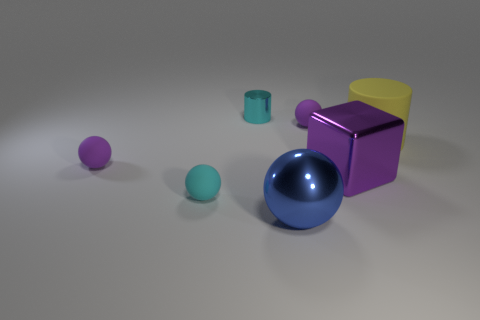Add 2 yellow spheres. How many objects exist? 9 Subtract 1 cylinders. How many cylinders are left? 1 Subtract all cyan matte spheres. How many spheres are left? 3 Subtract all purple balls. How many balls are left? 2 Subtract 0 gray balls. How many objects are left? 7 Subtract all blocks. How many objects are left? 6 Subtract all red cylinders. Subtract all yellow spheres. How many cylinders are left? 2 Subtract all gray cylinders. How many purple spheres are left? 2 Subtract all tiny cyan cylinders. Subtract all tiny objects. How many objects are left? 2 Add 4 large yellow rubber things. How many large yellow rubber things are left? 5 